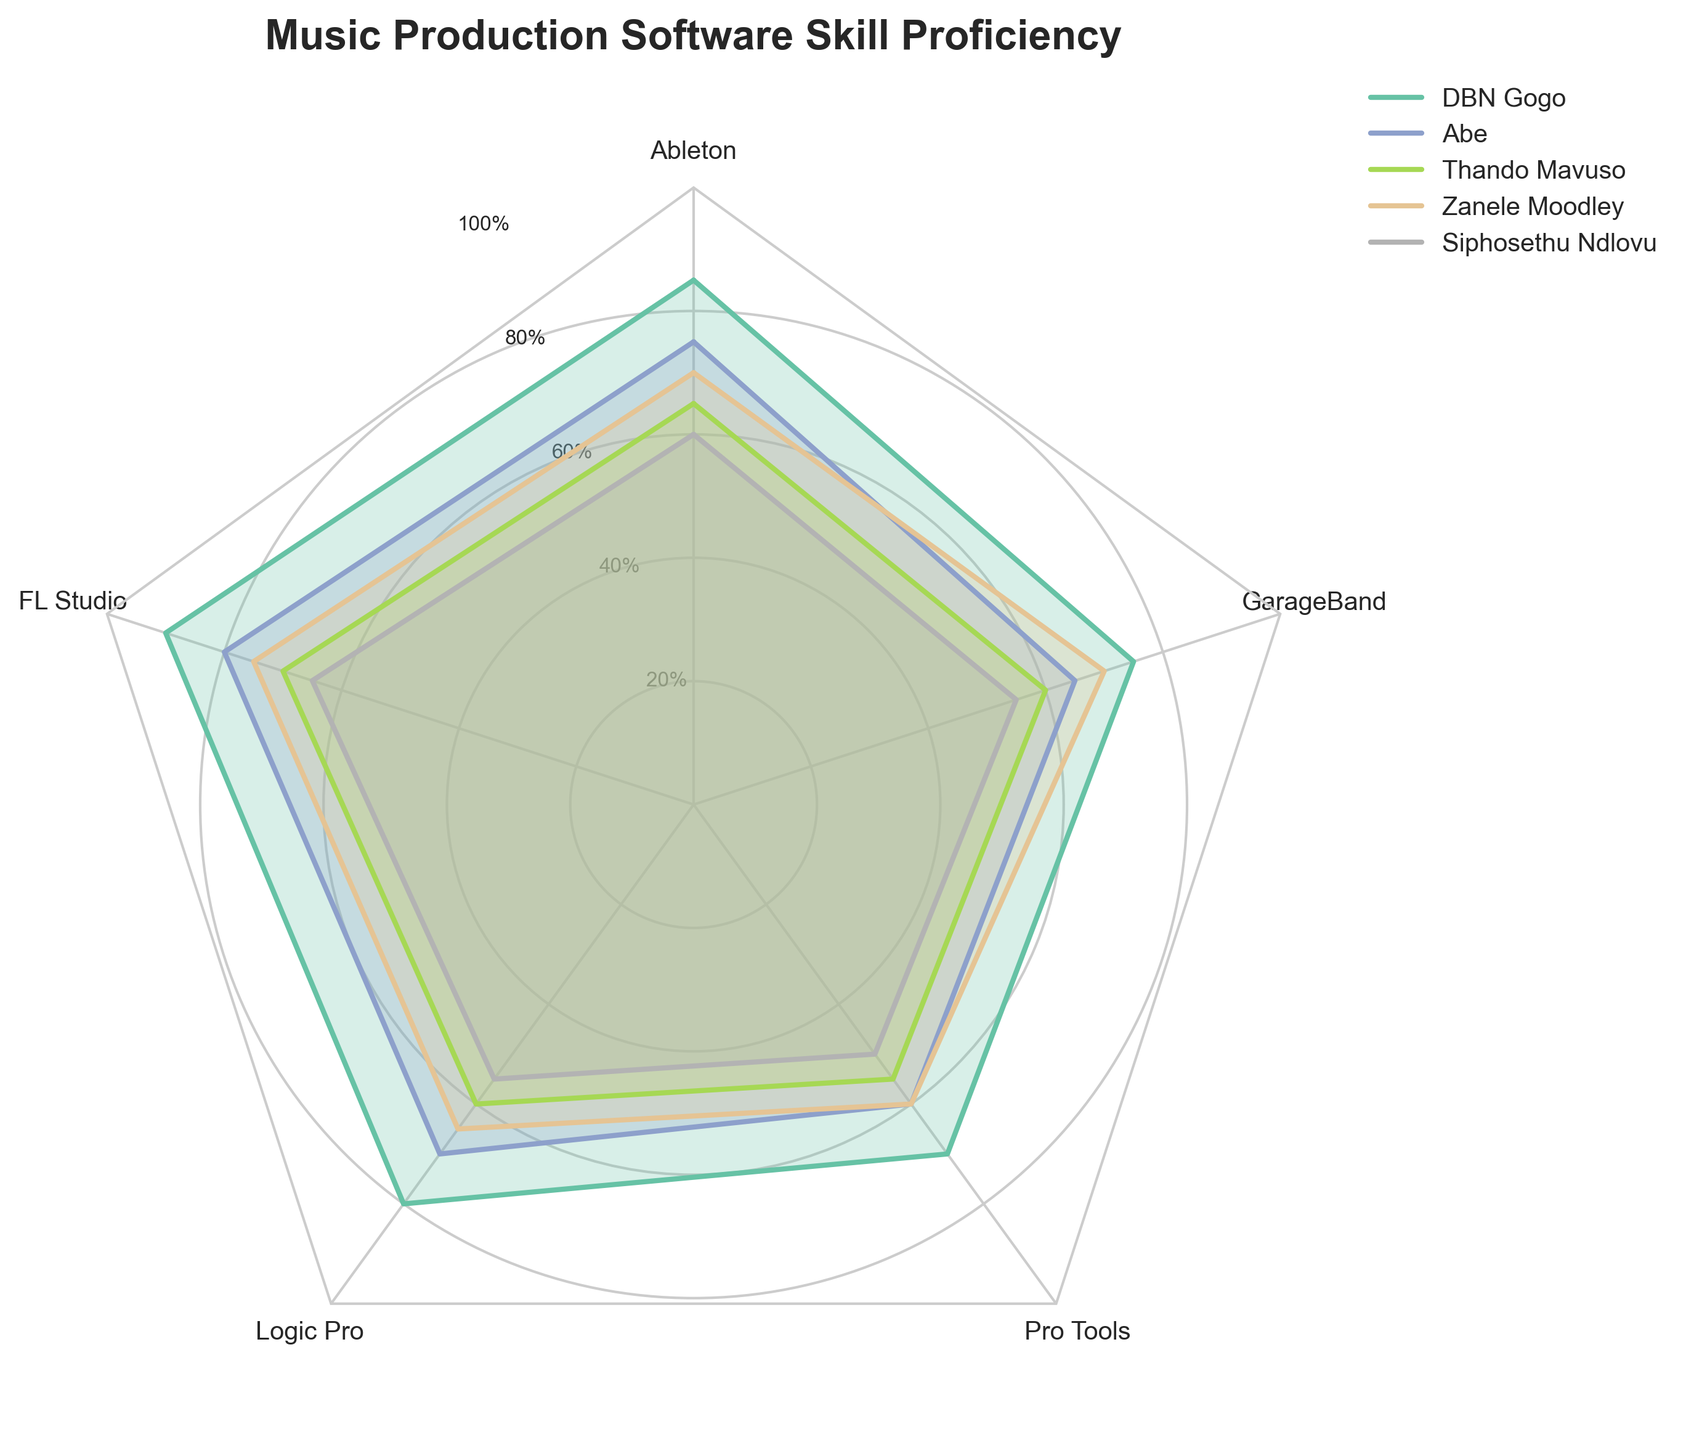Which music production software does DBN Gogo have the highest proficiency in? Based on the radar chart, DBN Gogo has the highest proficiency in FL Studio, with a score of 90.
Answer: FL Studio Which music production software does Siphosethu Ndlovu have the lowest proficiency in? The radar chart shows that Siphosethu Ndlovu has the lowest proficiency in Logic Pro, with a score of 55.
Answer: Logic Pro What is the average proficiency score of Zanele Moodley across all the listed software? Zanele Moodley's scores are 70 (Ableton), 75 (FL Studio), 65 (Logic Pro), 60 (Pro Tools), and 70 (GarageBand). The average is calculated as (70+75+65+60+70)/5 = 68.
Answer: 68 How does Abe's proficiency in Ableton compare to Thando Mavuso's? According to the radar chart, Abe has a proficiency score of 75 in Ableton, while Thando Mavuso has a score of 65. Abe's proficiency is 10 points higher.
Answer: Abe is 10 points higher Who has the highest proficiency score in Pro Tools? The radar chart indicates that DBN Gogo has the highest proficiency in Pro Tools with a score of 70.
Answer: DBN Gogo Compare the overall proficiency in GarageBand between DBN Gogo and the other four producers. DBN Gogo has a score of 75 in GarageBand. Abe has 65, Thando Mavuso has 60, Zanele Moodley has 70, and Siphosethu Ndlovu has 55. DBN Gogo's score is the highest among these producers, with Zanele Moodley being the closest.
Answer: DBN Gogo has the highest, with Zanele Moodley closest Which software do all producers have their lowest proficiency in? By inspecting the radar chart, each producer's lowest proficiency is in Pro Tools (DBN Gogo: 70, Abe: 60, Thando Mavuso: 55, Zanele Moodley: 60, Siphosethu Ndlovu: 50).
Answer: Pro Tools List the software in which Thando Mavuso has a higher proficiency score than Siphosethu Ndlovu. By comparing their scores, Thando Mavuso has higher proficiency than Siphosethu Ndlovu in Ableton (65 vs. 60), FL Studio (70 vs. 65), Logic Pro (60 vs. 55), Pro Tools (55 vs. 50), and GarageBand (60 vs. 55).
Answer: All the software What's the difference between DBN Gogo and Abe’s proficiency in FL Studio? DBN Gogo has a proficiency score of 90 in FL Studio, while Abe's score is 80. The difference is 90 - 80 = 10 points.
Answer: 10 points 